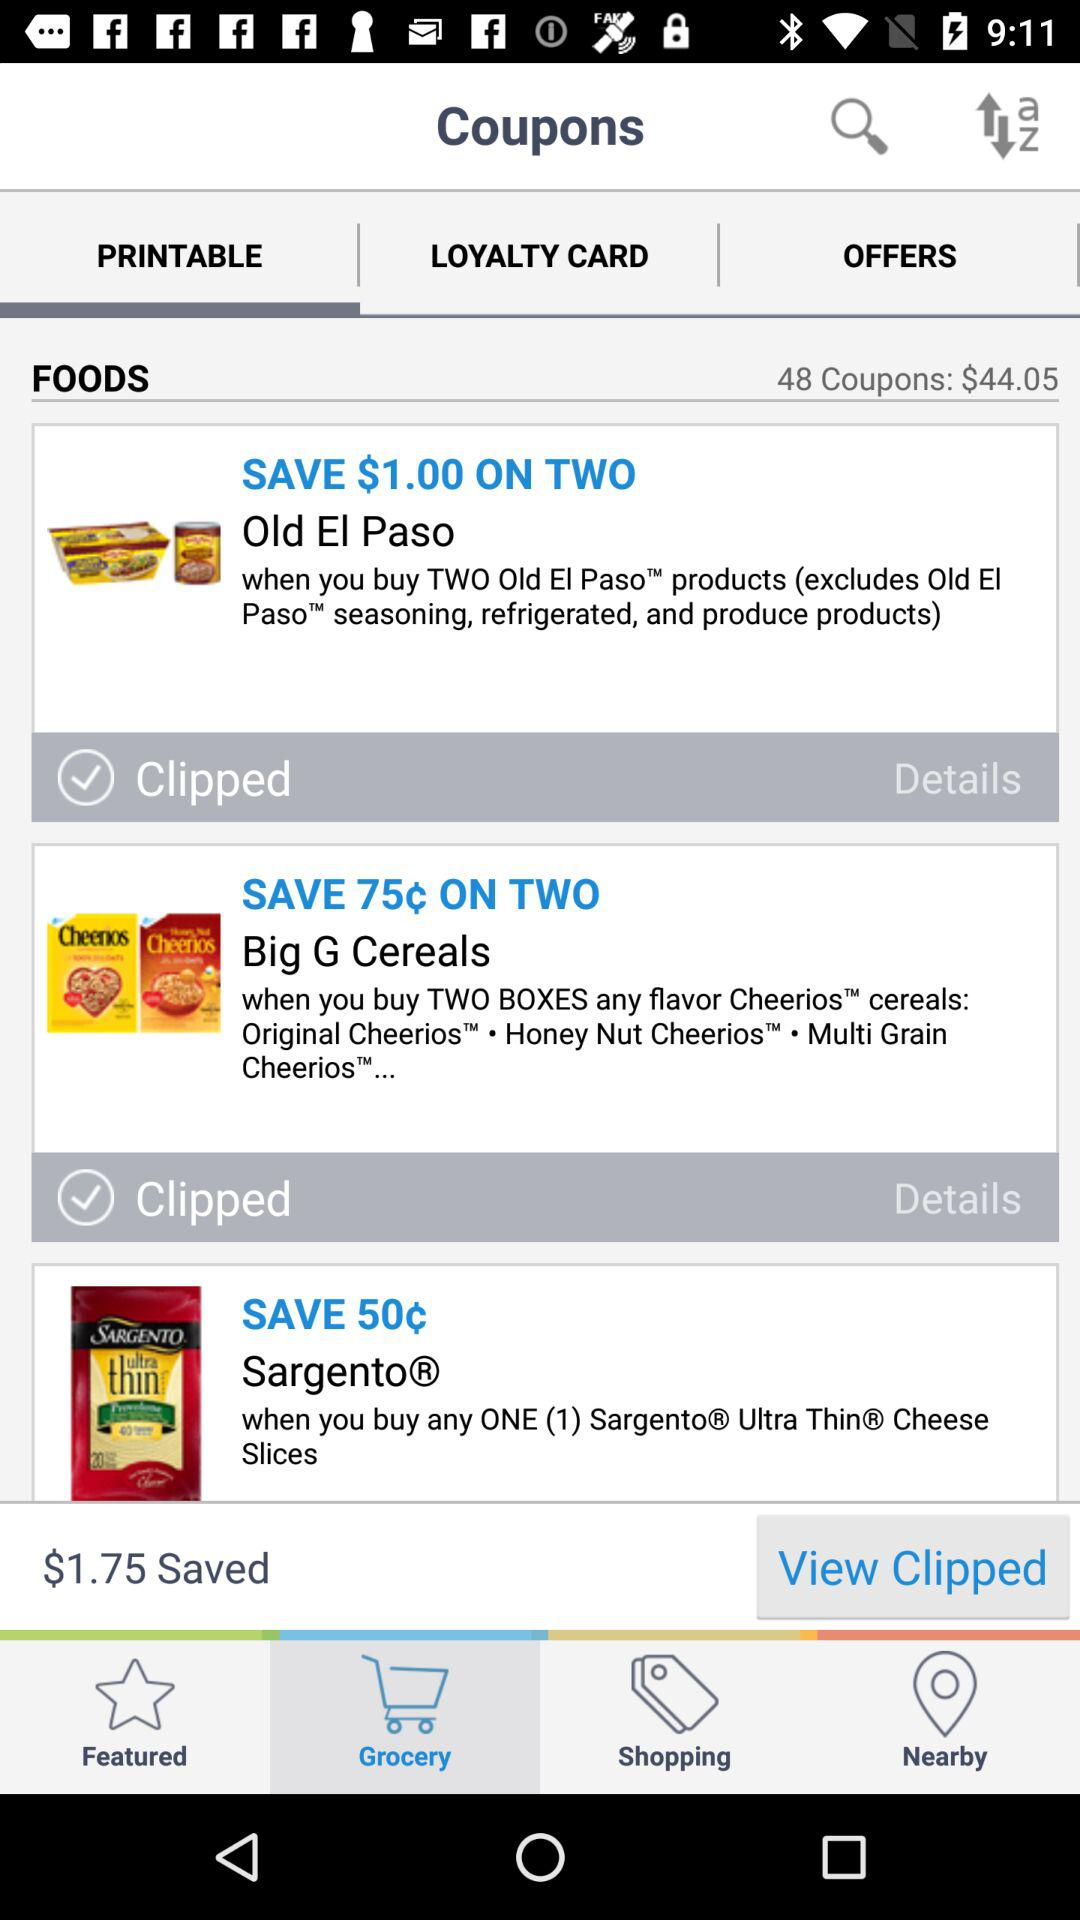What's the total number of coupons? The total number of coupons is 48. 